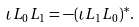<formula> <loc_0><loc_0><loc_500><loc_500>\iota { L _ { 0 } } { L _ { 1 } } = - ( \iota { L _ { 1 } } { L _ { 0 } } ) ^ { * } .</formula> 